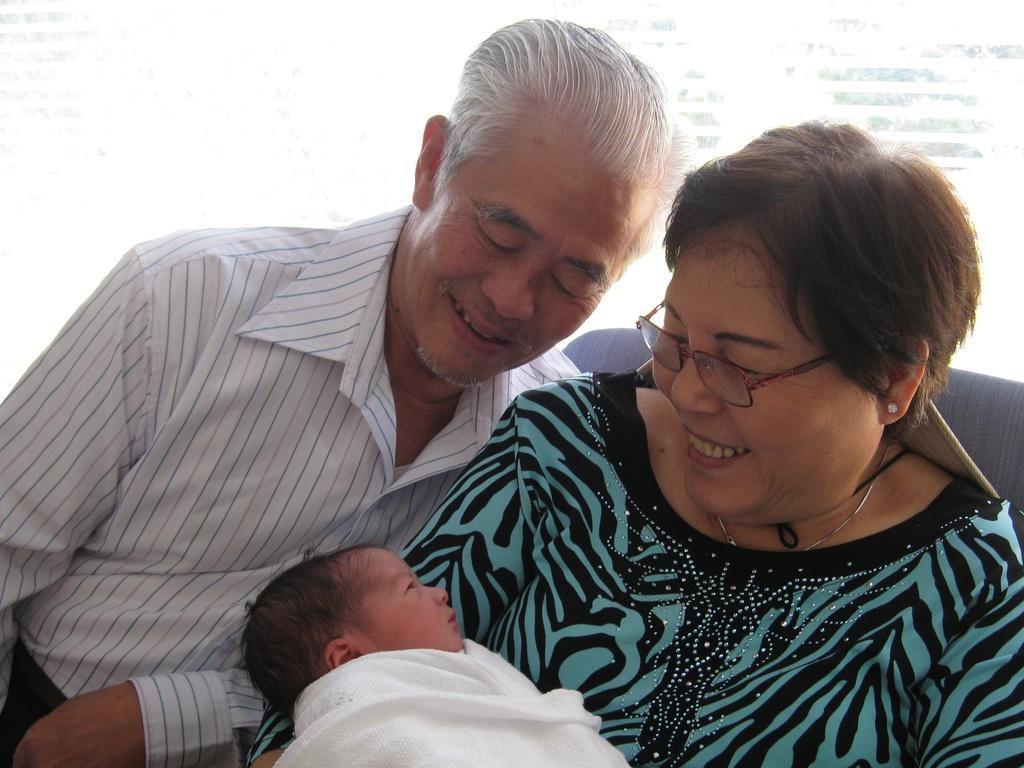Could you give a brief overview of what you see in this image? In this image we can see a two persons sitting and holding a baby. 